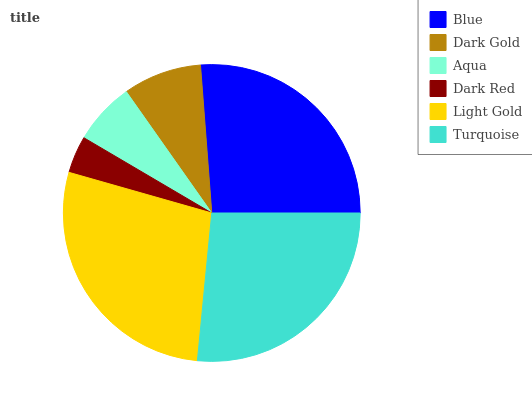Is Dark Red the minimum?
Answer yes or no. Yes. Is Light Gold the maximum?
Answer yes or no. Yes. Is Dark Gold the minimum?
Answer yes or no. No. Is Dark Gold the maximum?
Answer yes or no. No. Is Blue greater than Dark Gold?
Answer yes or no. Yes. Is Dark Gold less than Blue?
Answer yes or no. Yes. Is Dark Gold greater than Blue?
Answer yes or no. No. Is Blue less than Dark Gold?
Answer yes or no. No. Is Blue the high median?
Answer yes or no. Yes. Is Dark Gold the low median?
Answer yes or no. Yes. Is Aqua the high median?
Answer yes or no. No. Is Blue the low median?
Answer yes or no. No. 